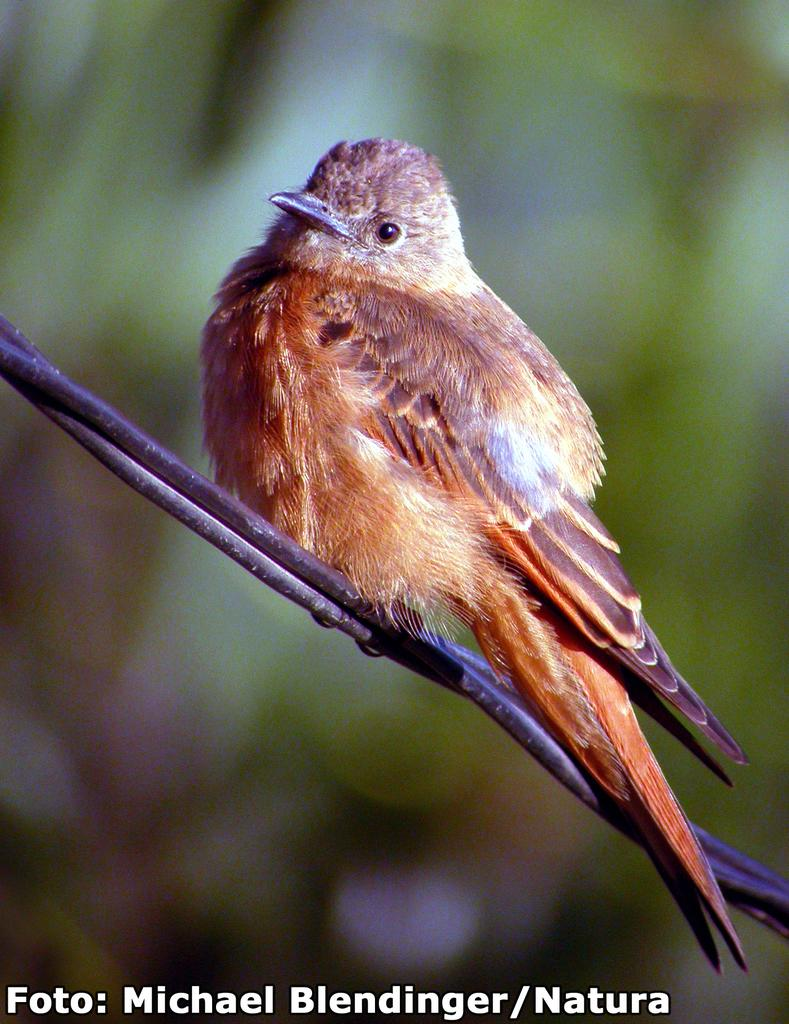What type of animal is in the image? There is a bird in the image. What color is the bird? The bird is brown in color. Where is the bird located in the image? The bird is on a wire. Can you describe the background of the image? The background of the image is blurred. Is there any additional information or markings on the image? Yes, there is a watermark in the image. What type of shoes is the bird wearing in the image? There are no shoes present in the image, as the bird is a bird and not a human or other creature that would wear shoes. 